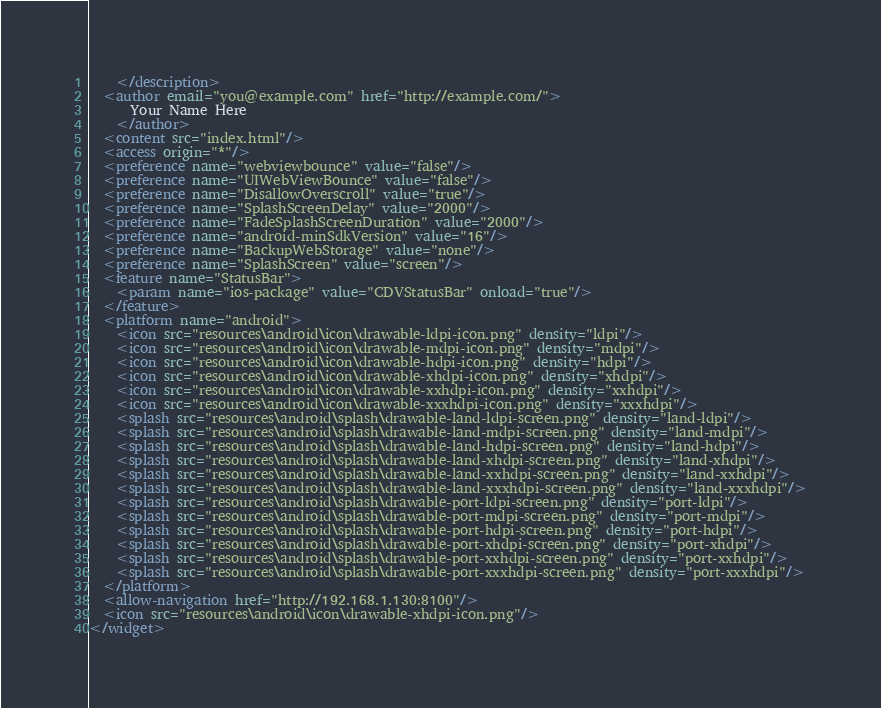<code> <loc_0><loc_0><loc_500><loc_500><_XML_>    </description>
  <author email="you@example.com" href="http://example.com/">
      Your Name Here
    </author>
  <content src="index.html"/>
  <access origin="*"/>
  <preference name="webviewbounce" value="false"/>
  <preference name="UIWebViewBounce" value="false"/>
  <preference name="DisallowOverscroll" value="true"/>
  <preference name="SplashScreenDelay" value="2000"/>
  <preference name="FadeSplashScreenDuration" value="2000"/>
  <preference name="android-minSdkVersion" value="16"/>
  <preference name="BackupWebStorage" value="none"/>
  <preference name="SplashScreen" value="screen"/>
  <feature name="StatusBar">
    <param name="ios-package" value="CDVStatusBar" onload="true"/>
  </feature>
  <platform name="android">
    <icon src="resources\android\icon\drawable-ldpi-icon.png" density="ldpi"/>
    <icon src="resources\android\icon\drawable-mdpi-icon.png" density="mdpi"/>
    <icon src="resources\android\icon\drawable-hdpi-icon.png" density="hdpi"/>
    <icon src="resources\android\icon\drawable-xhdpi-icon.png" density="xhdpi"/>
    <icon src="resources\android\icon\drawable-xxhdpi-icon.png" density="xxhdpi"/>
    <icon src="resources\android\icon\drawable-xxxhdpi-icon.png" density="xxxhdpi"/>
    <splash src="resources\android\splash\drawable-land-ldpi-screen.png" density="land-ldpi"/>
    <splash src="resources\android\splash\drawable-land-mdpi-screen.png" density="land-mdpi"/>
    <splash src="resources\android\splash\drawable-land-hdpi-screen.png" density="land-hdpi"/>
    <splash src="resources\android\splash\drawable-land-xhdpi-screen.png" density="land-xhdpi"/>
    <splash src="resources\android\splash\drawable-land-xxhdpi-screen.png" density="land-xxhdpi"/>
    <splash src="resources\android\splash\drawable-land-xxxhdpi-screen.png" density="land-xxxhdpi"/>
    <splash src="resources\android\splash\drawable-port-ldpi-screen.png" density="port-ldpi"/>
    <splash src="resources\android\splash\drawable-port-mdpi-screen.png" density="port-mdpi"/>
    <splash src="resources\android\splash\drawable-port-hdpi-screen.png" density="port-hdpi"/>
    <splash src="resources\android\splash\drawable-port-xhdpi-screen.png" density="port-xhdpi"/>
    <splash src="resources\android\splash\drawable-port-xxhdpi-screen.png" density="port-xxhdpi"/>
    <splash src="resources\android\splash\drawable-port-xxxhdpi-screen.png" density="port-xxxhdpi"/>
  </platform>
  <allow-navigation href="http://192.168.1.130:8100"/>
  <icon src="resources\android\icon\drawable-xhdpi-icon.png"/>
</widget></code> 